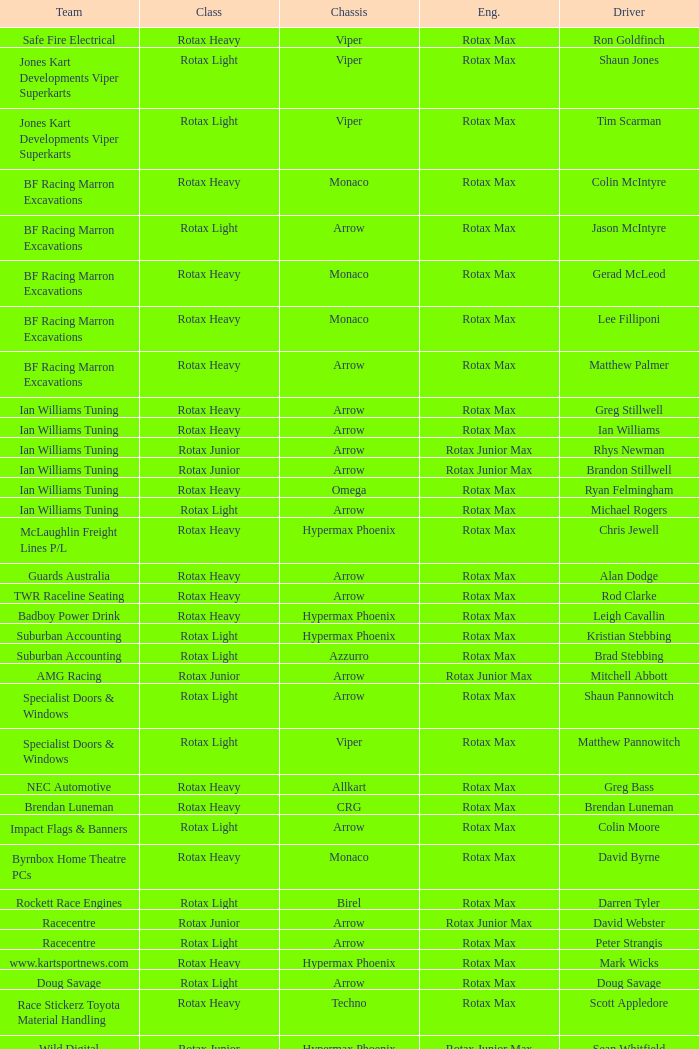Driver Shaun Jones with a viper as a chassis is in what class? Rotax Light. Would you mind parsing the complete table? {'header': ['Team', 'Class', 'Chassis', 'Eng.', 'Driver'], 'rows': [['Safe Fire Electrical', 'Rotax Heavy', 'Viper', 'Rotax Max', 'Ron Goldfinch'], ['Jones Kart Developments Viper Superkarts', 'Rotax Light', 'Viper', 'Rotax Max', 'Shaun Jones'], ['Jones Kart Developments Viper Superkarts', 'Rotax Light', 'Viper', 'Rotax Max', 'Tim Scarman'], ['BF Racing Marron Excavations', 'Rotax Heavy', 'Monaco', 'Rotax Max', 'Colin McIntyre'], ['BF Racing Marron Excavations', 'Rotax Light', 'Arrow', 'Rotax Max', 'Jason McIntyre'], ['BF Racing Marron Excavations', 'Rotax Heavy', 'Monaco', 'Rotax Max', 'Gerad McLeod'], ['BF Racing Marron Excavations', 'Rotax Heavy', 'Monaco', 'Rotax Max', 'Lee Filliponi'], ['BF Racing Marron Excavations', 'Rotax Heavy', 'Arrow', 'Rotax Max', 'Matthew Palmer'], ['Ian Williams Tuning', 'Rotax Heavy', 'Arrow', 'Rotax Max', 'Greg Stillwell'], ['Ian Williams Tuning', 'Rotax Heavy', 'Arrow', 'Rotax Max', 'Ian Williams'], ['Ian Williams Tuning', 'Rotax Junior', 'Arrow', 'Rotax Junior Max', 'Rhys Newman'], ['Ian Williams Tuning', 'Rotax Junior', 'Arrow', 'Rotax Junior Max', 'Brandon Stillwell'], ['Ian Williams Tuning', 'Rotax Heavy', 'Omega', 'Rotax Max', 'Ryan Felmingham'], ['Ian Williams Tuning', 'Rotax Light', 'Arrow', 'Rotax Max', 'Michael Rogers'], ['McLaughlin Freight Lines P/L', 'Rotax Heavy', 'Hypermax Phoenix', 'Rotax Max', 'Chris Jewell'], ['Guards Australia', 'Rotax Heavy', 'Arrow', 'Rotax Max', 'Alan Dodge'], ['TWR Raceline Seating', 'Rotax Heavy', 'Arrow', 'Rotax Max', 'Rod Clarke'], ['Badboy Power Drink', 'Rotax Heavy', 'Hypermax Phoenix', 'Rotax Max', 'Leigh Cavallin'], ['Suburban Accounting', 'Rotax Light', 'Hypermax Phoenix', 'Rotax Max', 'Kristian Stebbing'], ['Suburban Accounting', 'Rotax Light', 'Azzurro', 'Rotax Max', 'Brad Stebbing'], ['AMG Racing', 'Rotax Junior', 'Arrow', 'Rotax Junior Max', 'Mitchell Abbott'], ['Specialist Doors & Windows', 'Rotax Light', 'Arrow', 'Rotax Max', 'Shaun Pannowitch'], ['Specialist Doors & Windows', 'Rotax Light', 'Viper', 'Rotax Max', 'Matthew Pannowitch'], ['NEC Automotive', 'Rotax Heavy', 'Allkart', 'Rotax Max', 'Greg Bass'], ['Brendan Luneman', 'Rotax Heavy', 'CRG', 'Rotax Max', 'Brendan Luneman'], ['Impact Flags & Banners', 'Rotax Light', 'Arrow', 'Rotax Max', 'Colin Moore'], ['Byrnbox Home Theatre PCs', 'Rotax Heavy', 'Monaco', 'Rotax Max', 'David Byrne'], ['Rockett Race Engines', 'Rotax Light', 'Birel', 'Rotax Max', 'Darren Tyler'], ['Racecentre', 'Rotax Junior', 'Arrow', 'Rotax Junior Max', 'David Webster'], ['Racecentre', 'Rotax Light', 'Arrow', 'Rotax Max', 'Peter Strangis'], ['www.kartsportnews.com', 'Rotax Heavy', 'Hypermax Phoenix', 'Rotax Max', 'Mark Wicks'], ['Doug Savage', 'Rotax Light', 'Arrow', 'Rotax Max', 'Doug Savage'], ['Race Stickerz Toyota Material Handling', 'Rotax Heavy', 'Techno', 'Rotax Max', 'Scott Appledore'], ['Wild Digital', 'Rotax Junior', 'Hypermax Phoenix', 'Rotax Junior Max', 'Sean Whitfield'], ['John Bartlett', 'Rotax Heavy', 'Hypermax Phoenix', 'Rotax Max', 'John Bartlett']]} 